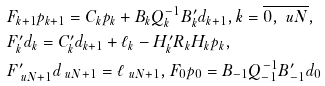<formula> <loc_0><loc_0><loc_500><loc_500>& F _ { k + 1 } p _ { k + 1 } = C _ { k } p _ { k } + B _ { k } Q ^ { - 1 } _ { k } B ^ { \prime } _ { k } d _ { k + 1 } , k = \overline { 0 , \ u N } , \\ & F ^ { \prime } _ { k } d _ { k } = C ^ { \prime } _ { k } d _ { k + 1 } + \ell _ { k } - H ^ { \prime } _ { k } R _ { k } H _ { k } p _ { k } , \\ & F ^ { \prime } _ { \ u N + 1 } d _ { \ u N + 1 } = \ell _ { \ u N + 1 } , F _ { 0 } p _ { 0 } = B _ { - 1 } Q _ { - 1 } ^ { - 1 } B ^ { \prime } _ { - 1 } d _ { 0 }</formula> 